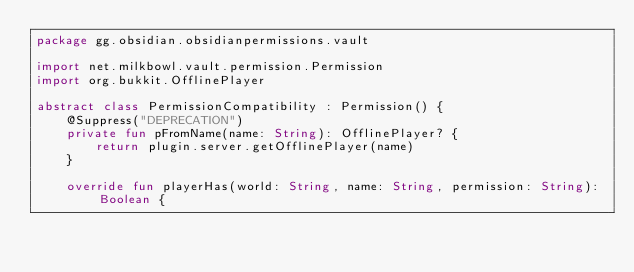<code> <loc_0><loc_0><loc_500><loc_500><_Kotlin_>package gg.obsidian.obsidianpermissions.vault

import net.milkbowl.vault.permission.Permission
import org.bukkit.OfflinePlayer

abstract class PermissionCompatibility : Permission() {
    @Suppress("DEPRECATION")
    private fun pFromName(name: String): OfflinePlayer? {
        return plugin.server.getOfflinePlayer(name)
    }

    override fun playerHas(world: String, name: String, permission: String): Boolean {</code> 